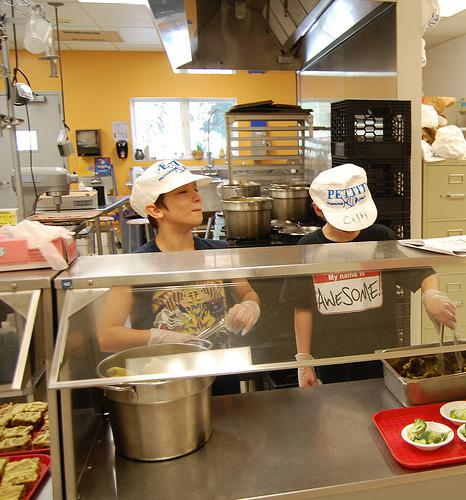Question: what color is the back wall?
Choices:
A. Brown.
B. Beige.
C. Yellow.
D. White.
Answer with the letter. Answer: C Question: what is written on the shirt of the right-hand person?
Choices:
A. Nike.
B. AWESOME.
C. Be happy.
D. Tgif.
Answer with the letter. Answer: B Question: where was this picture taken?
Choices:
A. A cafeteria.
B. A restaurant.
C. A bakery.
D. A pizzeria.
Answer with the letter. Answer: A Question: how many bowls are on the tray?
Choices:
A. Three.
B. One.
C. Two.
D. Four.
Answer with the letter. Answer: A Question: what is written on the bill of the right hat?
Choices:
A. Red Sox.
B. Tigers.
C. Yankees.
D. Colby.
Answer with the letter. Answer: D Question: what are the people doing?
Choices:
A. Serving food.
B. Eating food.
C. Sharing food.
D. Cooking food.
Answer with the letter. Answer: A 